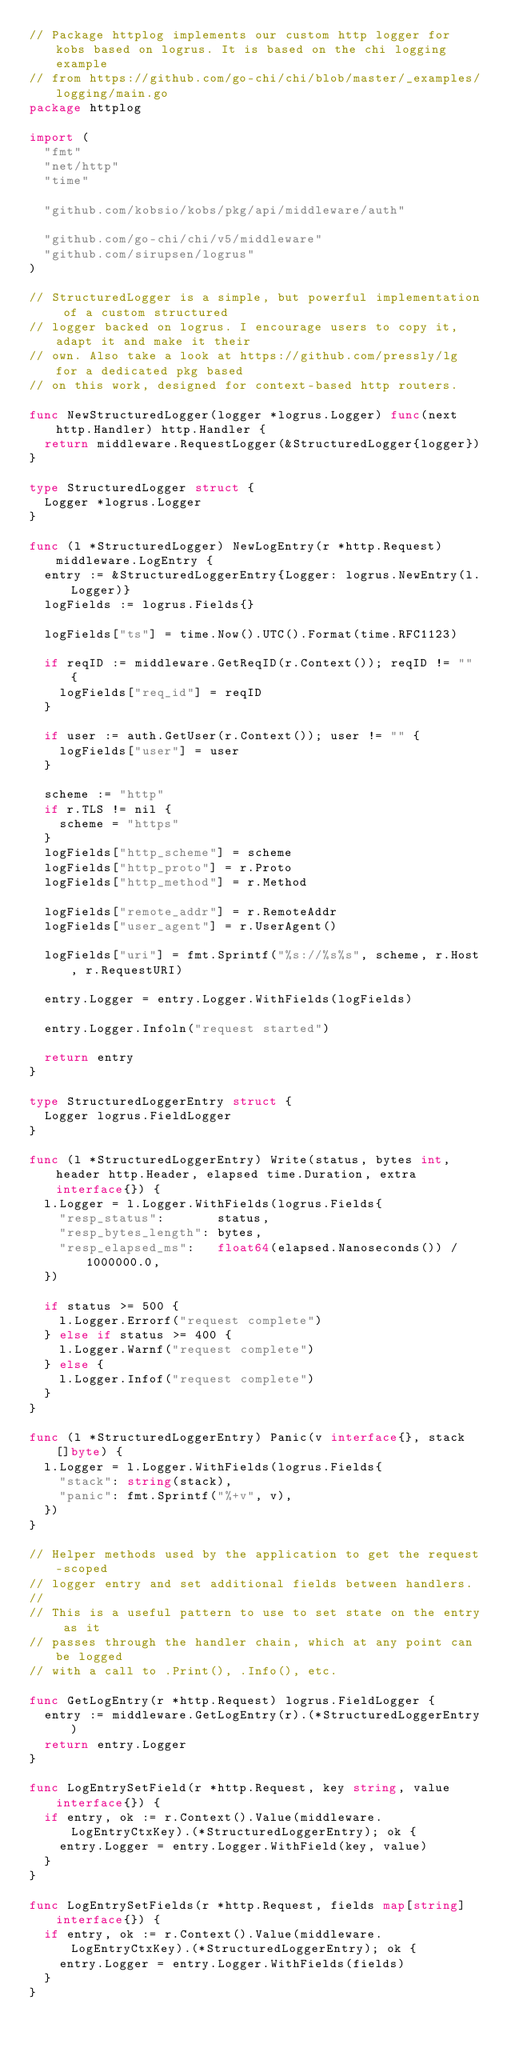Convert code to text. <code><loc_0><loc_0><loc_500><loc_500><_Go_>// Package httplog implements our custom http logger for kobs based on logrus. It is based on the chi logging example
// from https://github.com/go-chi/chi/blob/master/_examples/logging/main.go
package httplog

import (
	"fmt"
	"net/http"
	"time"

	"github.com/kobsio/kobs/pkg/api/middleware/auth"

	"github.com/go-chi/chi/v5/middleware"
	"github.com/sirupsen/logrus"
)

// StructuredLogger is a simple, but powerful implementation of a custom structured
// logger backed on logrus. I encourage users to copy it, adapt it and make it their
// own. Also take a look at https://github.com/pressly/lg for a dedicated pkg based
// on this work, designed for context-based http routers.

func NewStructuredLogger(logger *logrus.Logger) func(next http.Handler) http.Handler {
	return middleware.RequestLogger(&StructuredLogger{logger})
}

type StructuredLogger struct {
	Logger *logrus.Logger
}

func (l *StructuredLogger) NewLogEntry(r *http.Request) middleware.LogEntry {
	entry := &StructuredLoggerEntry{Logger: logrus.NewEntry(l.Logger)}
	logFields := logrus.Fields{}

	logFields["ts"] = time.Now().UTC().Format(time.RFC1123)

	if reqID := middleware.GetReqID(r.Context()); reqID != "" {
		logFields["req_id"] = reqID
	}

	if user := auth.GetUser(r.Context()); user != "" {
		logFields["user"] = user
	}

	scheme := "http"
	if r.TLS != nil {
		scheme = "https"
	}
	logFields["http_scheme"] = scheme
	logFields["http_proto"] = r.Proto
	logFields["http_method"] = r.Method

	logFields["remote_addr"] = r.RemoteAddr
	logFields["user_agent"] = r.UserAgent()

	logFields["uri"] = fmt.Sprintf("%s://%s%s", scheme, r.Host, r.RequestURI)

	entry.Logger = entry.Logger.WithFields(logFields)

	entry.Logger.Infoln("request started")

	return entry
}

type StructuredLoggerEntry struct {
	Logger logrus.FieldLogger
}

func (l *StructuredLoggerEntry) Write(status, bytes int, header http.Header, elapsed time.Duration, extra interface{}) {
	l.Logger = l.Logger.WithFields(logrus.Fields{
		"resp_status":       status,
		"resp_bytes_length": bytes,
		"resp_elapsed_ms":   float64(elapsed.Nanoseconds()) / 1000000.0,
	})

	if status >= 500 {
		l.Logger.Errorf("request complete")
	} else if status >= 400 {
		l.Logger.Warnf("request complete")
	} else {
		l.Logger.Infof("request complete")
	}
}

func (l *StructuredLoggerEntry) Panic(v interface{}, stack []byte) {
	l.Logger = l.Logger.WithFields(logrus.Fields{
		"stack": string(stack),
		"panic": fmt.Sprintf("%+v", v),
	})
}

// Helper methods used by the application to get the request-scoped
// logger entry and set additional fields between handlers.
//
// This is a useful pattern to use to set state on the entry as it
// passes through the handler chain, which at any point can be logged
// with a call to .Print(), .Info(), etc.

func GetLogEntry(r *http.Request) logrus.FieldLogger {
	entry := middleware.GetLogEntry(r).(*StructuredLoggerEntry)
	return entry.Logger
}

func LogEntrySetField(r *http.Request, key string, value interface{}) {
	if entry, ok := r.Context().Value(middleware.LogEntryCtxKey).(*StructuredLoggerEntry); ok {
		entry.Logger = entry.Logger.WithField(key, value)
	}
}

func LogEntrySetFields(r *http.Request, fields map[string]interface{}) {
	if entry, ok := r.Context().Value(middleware.LogEntryCtxKey).(*StructuredLoggerEntry); ok {
		entry.Logger = entry.Logger.WithFields(fields)
	}
}
</code> 